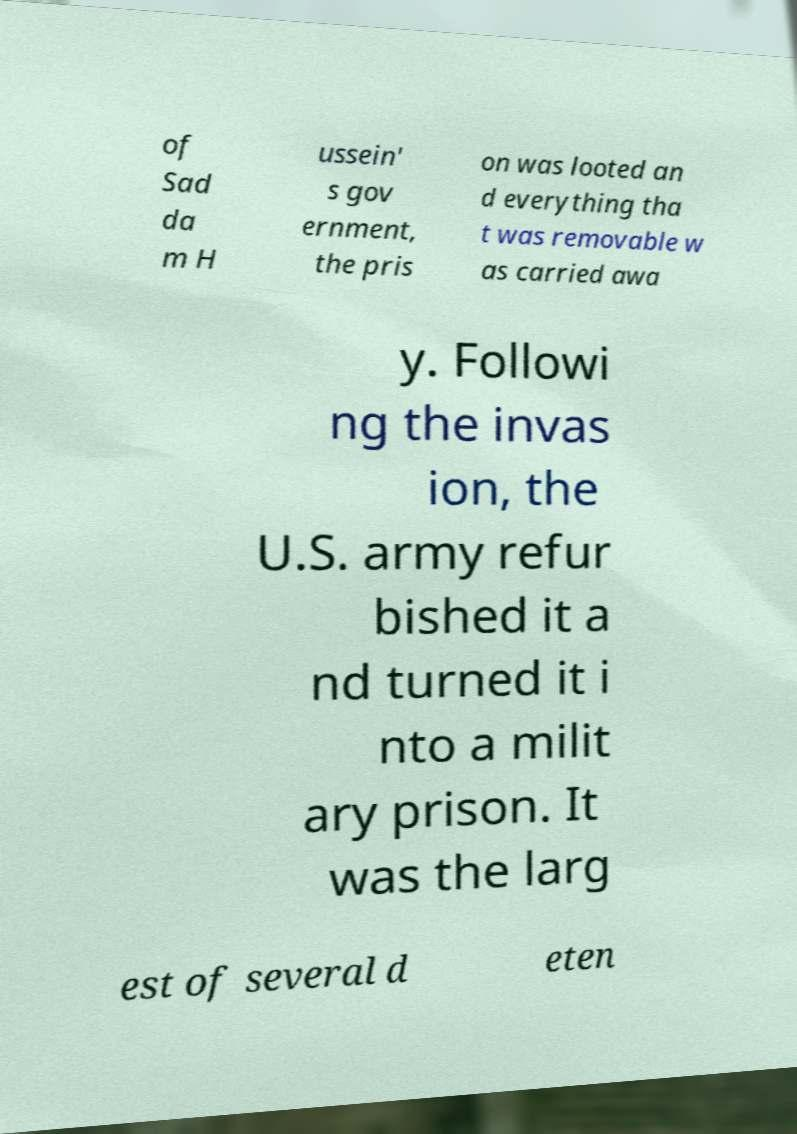Please read and relay the text visible in this image. What does it say? of Sad da m H ussein' s gov ernment, the pris on was looted an d everything tha t was removable w as carried awa y. Followi ng the invas ion, the U.S. army refur bished it a nd turned it i nto a milit ary prison. It was the larg est of several d eten 